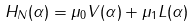<formula> <loc_0><loc_0><loc_500><loc_500>H _ { N } ( \alpha ) = \mu _ { 0 } V ( \alpha ) + \mu _ { 1 } L ( \alpha )</formula> 